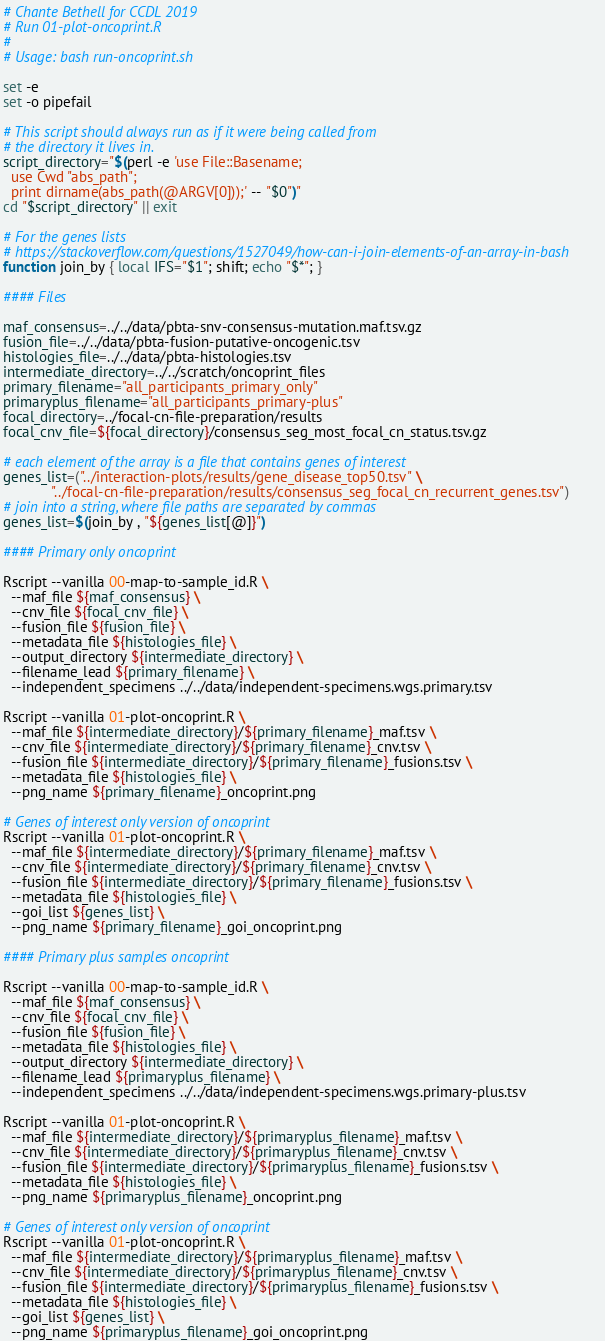Convert code to text. <code><loc_0><loc_0><loc_500><loc_500><_Bash_># Chante Bethell for CCDL 2019
# Run 01-plot-oncoprint.R
#
# Usage: bash run-oncoprint.sh

set -e
set -o pipefail

# This script should always run as if it were being called from
# the directory it lives in.
script_directory="$(perl -e 'use File::Basename;
  use Cwd "abs_path";
  print dirname(abs_path(@ARGV[0]));' -- "$0")"
cd "$script_directory" || exit

# For the genes lists
# https://stackoverflow.com/questions/1527049/how-can-i-join-elements-of-an-array-in-bash
function join_by { local IFS="$1"; shift; echo "$*"; }

#### Files

maf_consensus=../../data/pbta-snv-consensus-mutation.maf.tsv.gz
fusion_file=../../data/pbta-fusion-putative-oncogenic.tsv
histologies_file=../../data/pbta-histologies.tsv
intermediate_directory=../../scratch/oncoprint_files
primary_filename="all_participants_primary_only"
primaryplus_filename="all_participants_primary-plus"
focal_directory=../focal-cn-file-preparation/results
focal_cnv_file=${focal_directory}/consensus_seg_most_focal_cn_status.tsv.gz

# each element of the array is a file that contains genes of interest
genes_list=("../interaction-plots/results/gene_disease_top50.tsv" \
            "../focal-cn-file-preparation/results/consensus_seg_focal_cn_recurrent_genes.tsv")
# join into a string, where file paths are separated by commas
genes_list=$(join_by , "${genes_list[@]}")

#### Primary only oncoprint

Rscript --vanilla 00-map-to-sample_id.R \
  --maf_file ${maf_consensus} \
  --cnv_file ${focal_cnv_file} \
  --fusion_file ${fusion_file} \
  --metadata_file ${histologies_file} \
  --output_directory ${intermediate_directory} \
  --filename_lead ${primary_filename} \
  --independent_specimens ../../data/independent-specimens.wgs.primary.tsv

Rscript --vanilla 01-plot-oncoprint.R \
  --maf_file ${intermediate_directory}/${primary_filename}_maf.tsv \
  --cnv_file ${intermediate_directory}/${primary_filename}_cnv.tsv \
  --fusion_file ${intermediate_directory}/${primary_filename}_fusions.tsv \
  --metadata_file ${histologies_file} \
  --png_name ${primary_filename}_oncoprint.png

# Genes of interest only version of oncoprint
Rscript --vanilla 01-plot-oncoprint.R \
  --maf_file ${intermediate_directory}/${primary_filename}_maf.tsv \
  --cnv_file ${intermediate_directory}/${primary_filename}_cnv.tsv \
  --fusion_file ${intermediate_directory}/${primary_filename}_fusions.tsv \
  --metadata_file ${histologies_file} \
  --goi_list ${genes_list} \
  --png_name ${primary_filename}_goi_oncoprint.png

#### Primary plus samples oncoprint

Rscript --vanilla 00-map-to-sample_id.R \
  --maf_file ${maf_consensus} \
  --cnv_file ${focal_cnv_file} \
  --fusion_file ${fusion_file} \
  --metadata_file ${histologies_file} \
  --output_directory ${intermediate_directory} \
  --filename_lead ${primaryplus_filename} \
  --independent_specimens ../../data/independent-specimens.wgs.primary-plus.tsv

Rscript --vanilla 01-plot-oncoprint.R \
  --maf_file ${intermediate_directory}/${primaryplus_filename}_maf.tsv \
  --cnv_file ${intermediate_directory}/${primaryplus_filename}_cnv.tsv \
  --fusion_file ${intermediate_directory}/${primaryplus_filename}_fusions.tsv \
  --metadata_file ${histologies_file} \
  --png_name ${primaryplus_filename}_oncoprint.png

# Genes of interest only version of oncoprint
Rscript --vanilla 01-plot-oncoprint.R \
  --maf_file ${intermediate_directory}/${primaryplus_filename}_maf.tsv \
  --cnv_file ${intermediate_directory}/${primaryplus_filename}_cnv.tsv \
  --fusion_file ${intermediate_directory}/${primaryplus_filename}_fusions.tsv \
  --metadata_file ${histologies_file} \
  --goi_list ${genes_list} \
  --png_name ${primaryplus_filename}_goi_oncoprint.png
</code> 